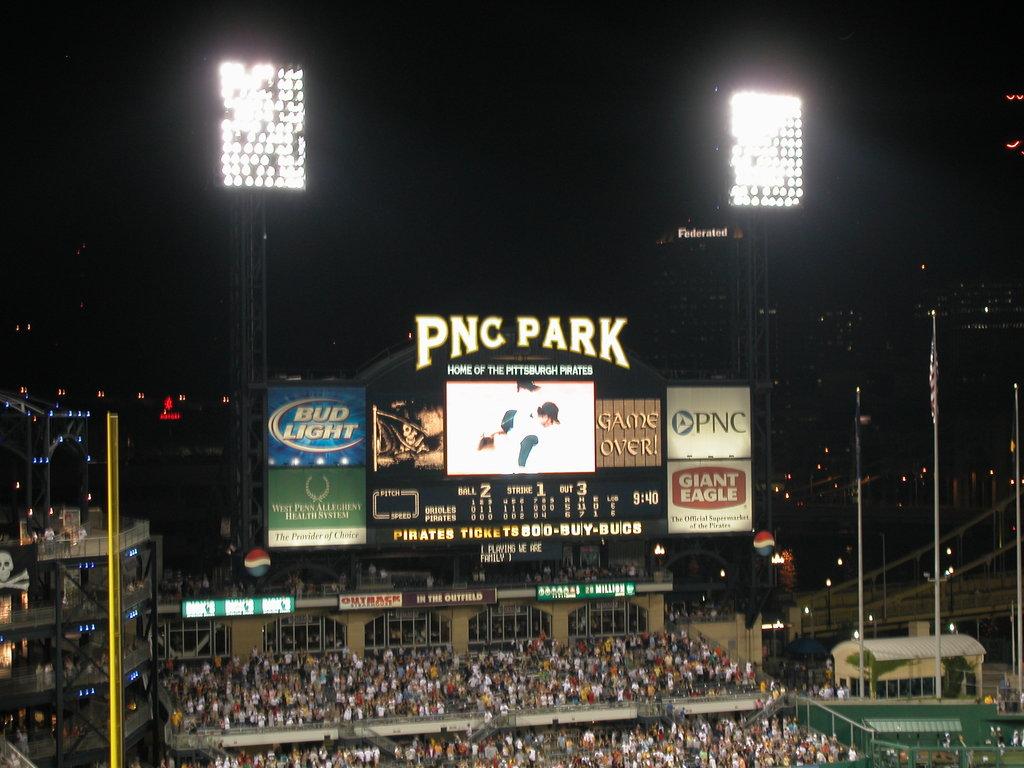What's this park called?
Provide a short and direct response. Pnc park. What beer sponsor is being advertised?
Offer a very short reply. Bud light. 